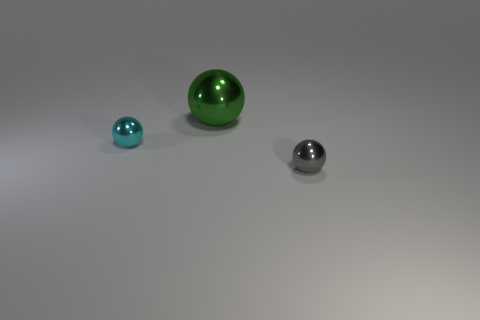The shiny object that is behind the tiny thing behind the tiny metal sphere that is in front of the small cyan ball is what color?
Offer a terse response. Green. Are there any small metallic objects that have the same shape as the large green metallic object?
Keep it short and to the point. Yes. How many small gray cubes are there?
Your response must be concise. 0. What is the shape of the tiny gray thing?
Your response must be concise. Sphere. How many other green shiny balls have the same size as the green ball?
Provide a short and direct response. 0. Does the green metallic object have the same shape as the gray thing?
Make the answer very short. Yes. There is a metallic sphere that is in front of the tiny metal thing that is left of the tiny gray ball; what color is it?
Offer a very short reply. Gray. There is a metal object that is both in front of the big ball and on the right side of the tiny cyan metallic thing; how big is it?
Your answer should be compact. Small. Is there anything else that has the same color as the big thing?
Make the answer very short. No. There is a large green object that is the same material as the tiny gray ball; what is its shape?
Give a very brief answer. Sphere. 